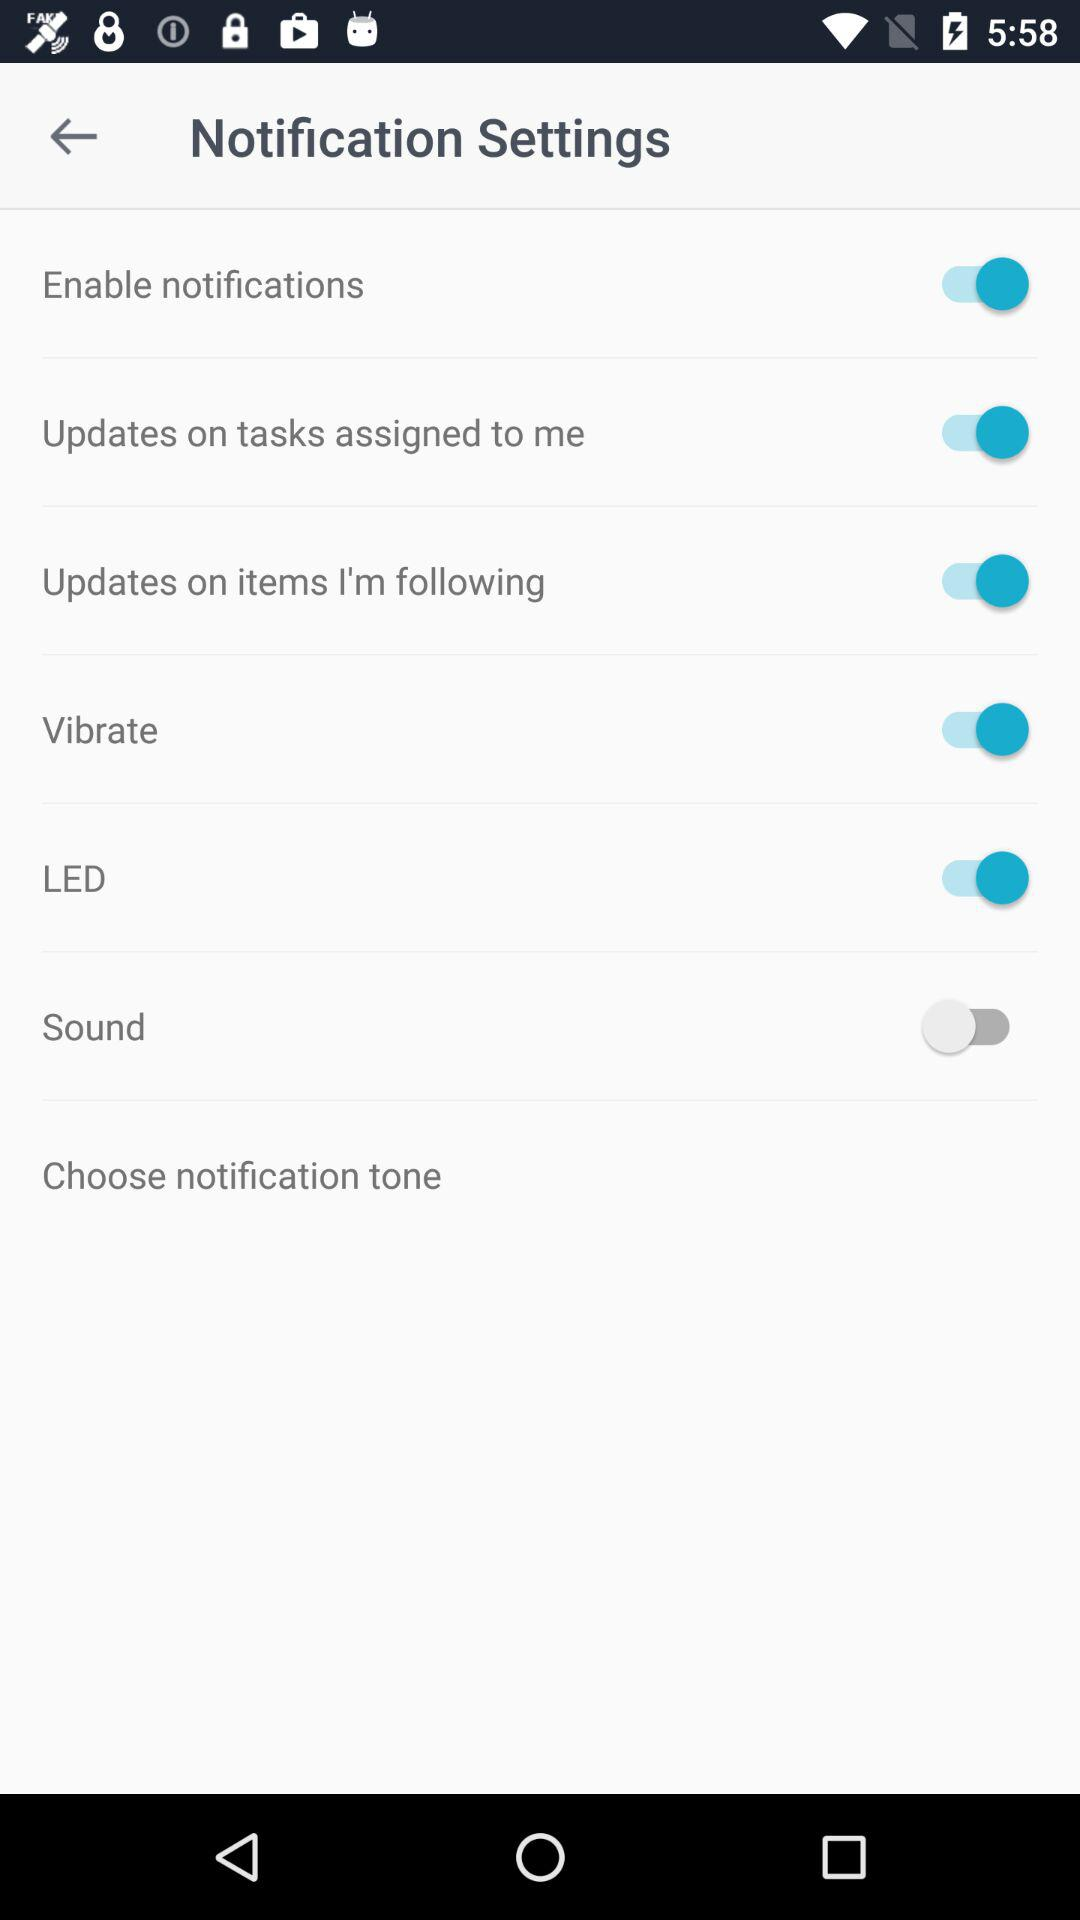Which setting options are on? The options are "Enable notifications", "Updates on tasks assigned to me", "Updates on items I'm following", "Vibrate" and "LED". 